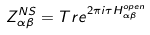<formula> <loc_0><loc_0><loc_500><loc_500>Z _ { \alpha \beta } ^ { N S } = T r e ^ { 2 \pi i \tau H _ { \alpha \beta } ^ { o p e n } }</formula> 